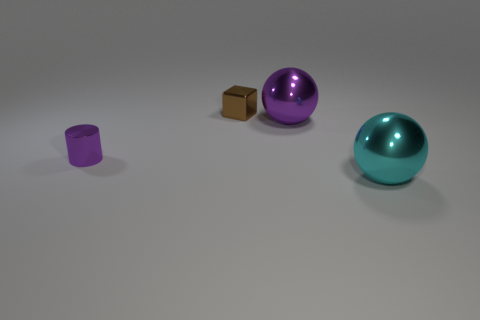Are there more large shiny spheres than green rubber spheres?
Offer a very short reply. Yes. Does the ball behind the small metallic cylinder have the same color as the object that is on the left side of the brown metal cube?
Keep it short and to the point. Yes. Does the large object that is left of the cyan ball have the same material as the tiny object in front of the small brown object?
Keep it short and to the point. Yes. What number of other brown metallic cubes have the same size as the block?
Provide a short and direct response. 0. Is the number of yellow matte objects less than the number of brown objects?
Provide a short and direct response. Yes. There is a tiny object that is behind the tiny thing that is in front of the small brown cube; what is its shape?
Keep it short and to the point. Cube. The object that is the same size as the brown metal block is what shape?
Offer a terse response. Cylinder. Is there a green object of the same shape as the cyan thing?
Keep it short and to the point. No. What material is the brown object?
Give a very brief answer. Metal. There is a brown shiny object; are there any small purple shiny things on the right side of it?
Give a very brief answer. No. 